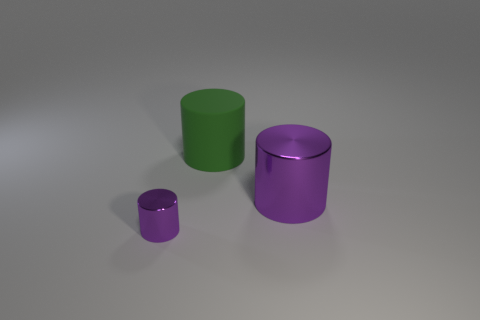Add 2 large green metallic spheres. How many objects exist? 5 Subtract all big cylinders. Subtract all green cylinders. How many objects are left? 0 Add 3 big green matte objects. How many big green matte objects are left? 4 Add 1 small gray shiny things. How many small gray shiny things exist? 1 Subtract 0 blue balls. How many objects are left? 3 